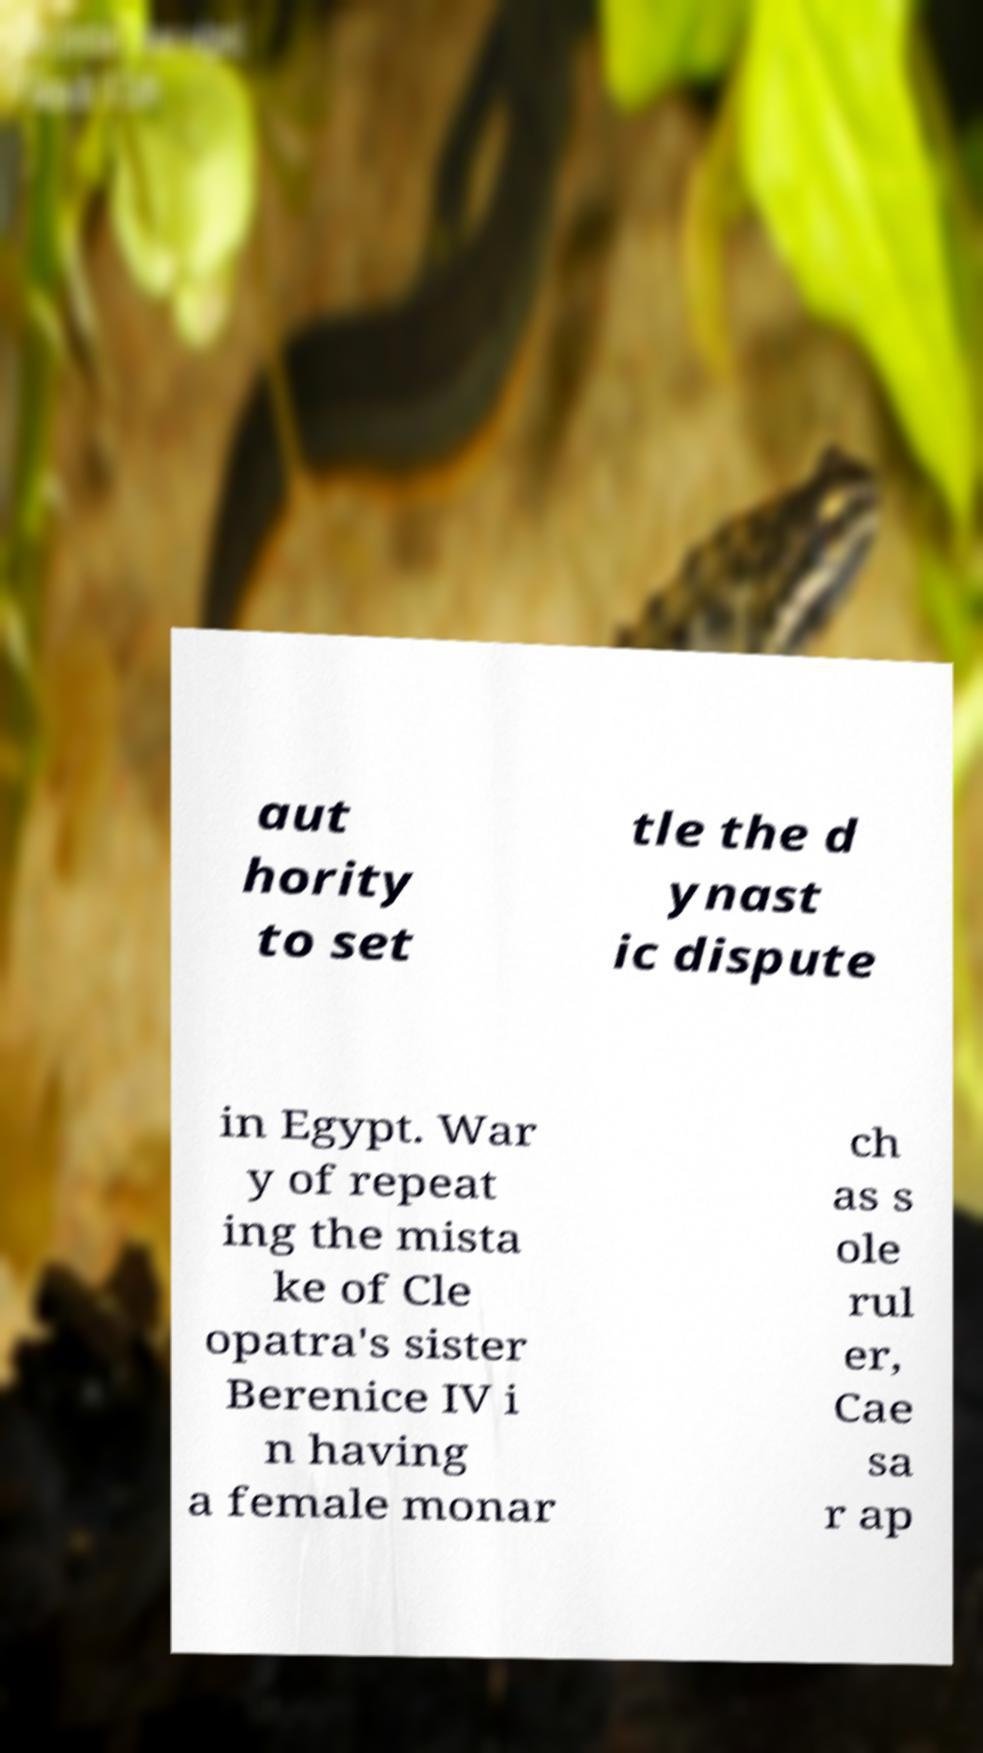Can you accurately transcribe the text from the provided image for me? aut hority to set tle the d ynast ic dispute in Egypt. War y of repeat ing the mista ke of Cle opatra's sister Berenice IV i n having a female monar ch as s ole rul er, Cae sa r ap 